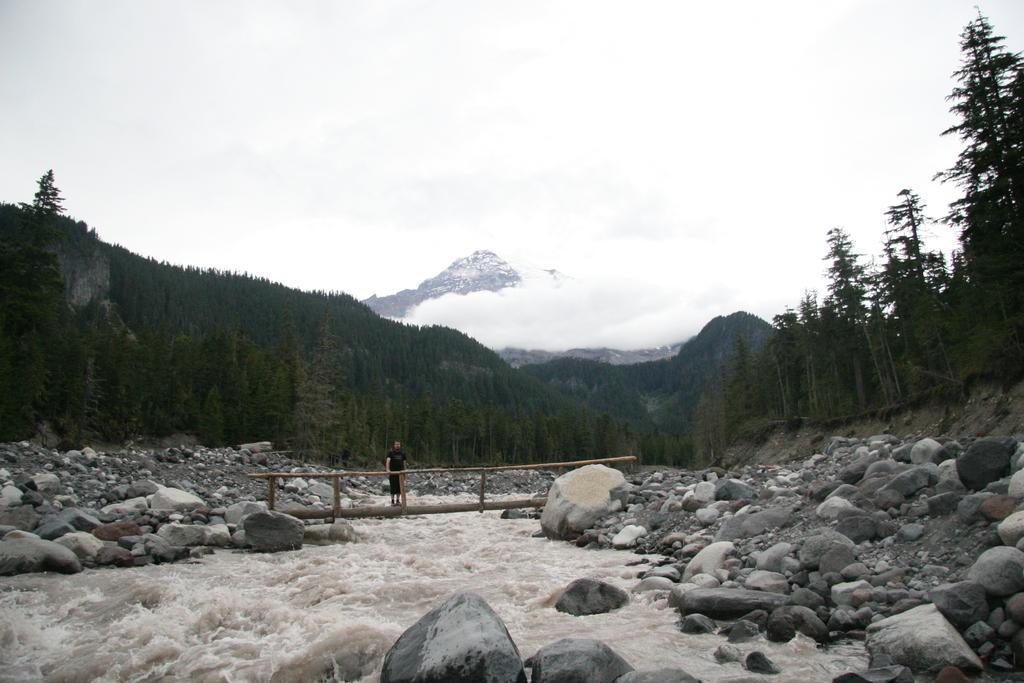Could you give a brief overview of what you see in this image? In the center of the image there is water. There are rocks. There is a person standing on the bridge. In the background of the image there are trees, mountains and sky. 